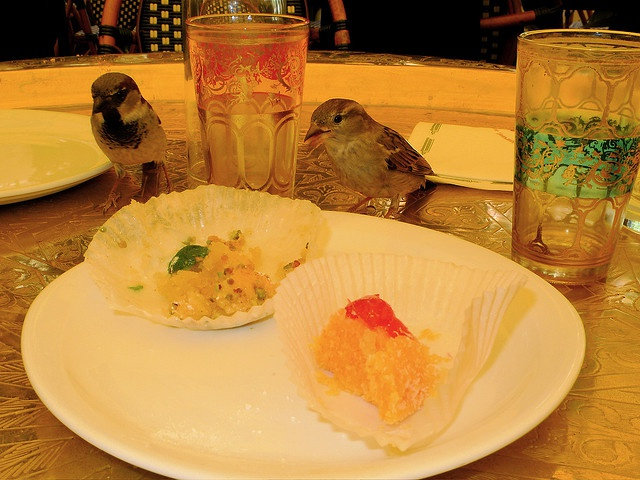Describe the objects in this image and their specific colors. I can see dining table in orange, brown, black, and tan tones, cup in black, olive, and orange tones, cup in black, red, orange, and brown tones, bird in black, brown, and maroon tones, and people in black, maroon, brown, and olive tones in this image. 